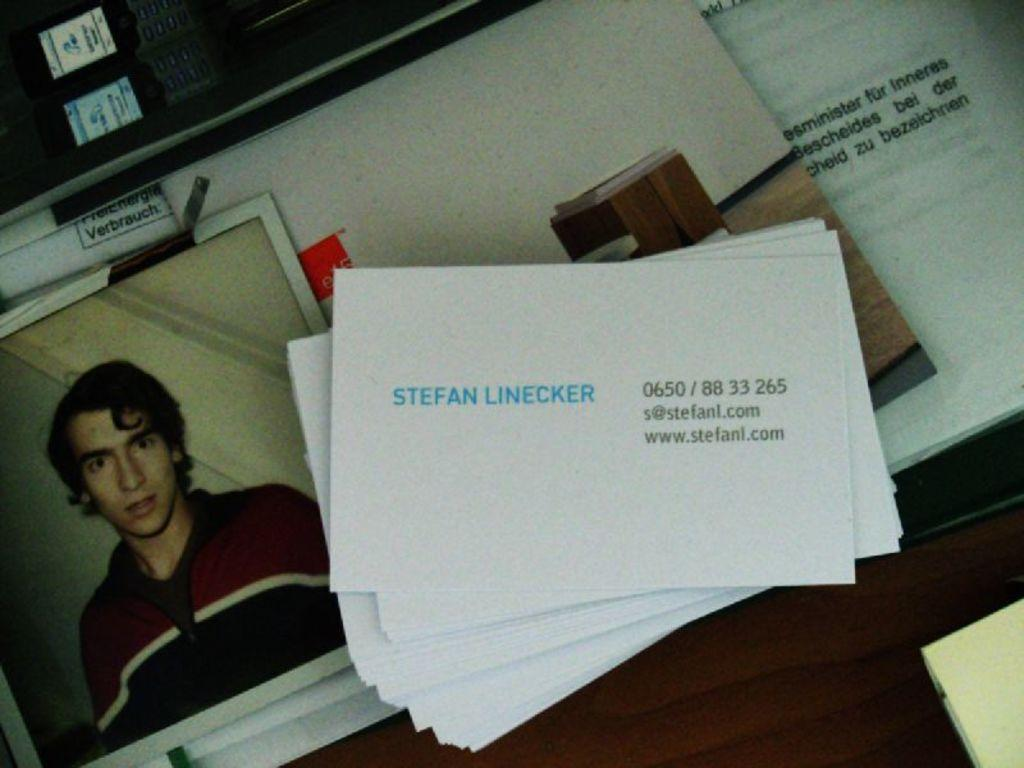<image>
Write a terse but informative summary of the picture. the name Stefan Linecker is on the white paper 